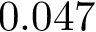<formula> <loc_0><loc_0><loc_500><loc_500>0 . 0 4 7</formula> 